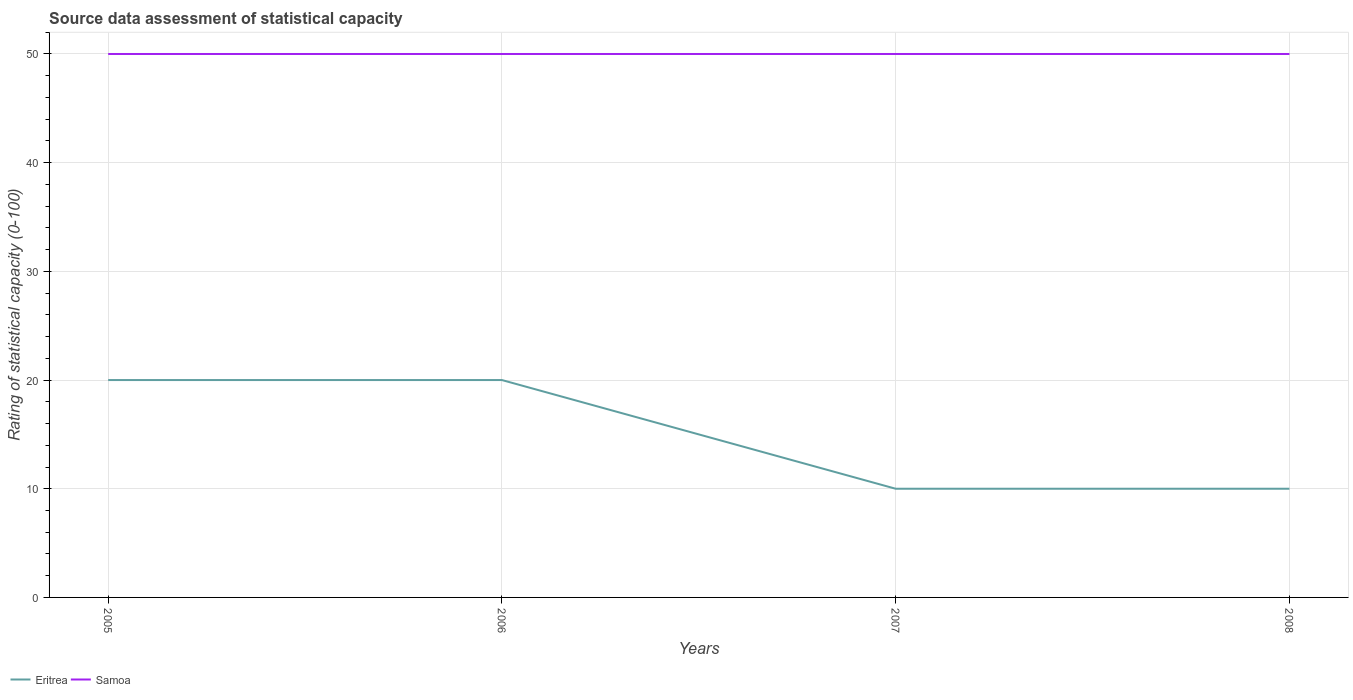How many different coloured lines are there?
Your answer should be very brief. 2. Is the number of lines equal to the number of legend labels?
Ensure brevity in your answer.  Yes. Across all years, what is the maximum rating of statistical capacity in Eritrea?
Give a very brief answer. 10. In which year was the rating of statistical capacity in Eritrea maximum?
Ensure brevity in your answer.  2007. What is the total rating of statistical capacity in Eritrea in the graph?
Your answer should be compact. 10. How many years are there in the graph?
Ensure brevity in your answer.  4. Are the values on the major ticks of Y-axis written in scientific E-notation?
Your response must be concise. No. Does the graph contain any zero values?
Offer a terse response. No. Does the graph contain grids?
Make the answer very short. Yes. How are the legend labels stacked?
Provide a short and direct response. Horizontal. What is the title of the graph?
Make the answer very short. Source data assessment of statistical capacity. Does "Pacific island small states" appear as one of the legend labels in the graph?
Give a very brief answer. No. What is the label or title of the Y-axis?
Your response must be concise. Rating of statistical capacity (0-100). What is the Rating of statistical capacity (0-100) in Samoa in 2006?
Your answer should be compact. 50. What is the Rating of statistical capacity (0-100) of Samoa in 2007?
Offer a terse response. 50. Across all years, what is the maximum Rating of statistical capacity (0-100) in Eritrea?
Ensure brevity in your answer.  20. Across all years, what is the maximum Rating of statistical capacity (0-100) of Samoa?
Your answer should be compact. 50. What is the total Rating of statistical capacity (0-100) of Samoa in the graph?
Your response must be concise. 200. What is the difference between the Rating of statistical capacity (0-100) in Eritrea in 2005 and that in 2007?
Ensure brevity in your answer.  10. What is the difference between the Rating of statistical capacity (0-100) in Samoa in 2005 and that in 2007?
Provide a short and direct response. 0. What is the difference between the Rating of statistical capacity (0-100) in Eritrea in 2005 and that in 2008?
Make the answer very short. 10. What is the difference between the Rating of statistical capacity (0-100) in Samoa in 2005 and that in 2008?
Provide a short and direct response. 0. What is the difference between the Rating of statistical capacity (0-100) in Samoa in 2006 and that in 2008?
Your response must be concise. 0. What is the difference between the Rating of statistical capacity (0-100) of Eritrea in 2005 and the Rating of statistical capacity (0-100) of Samoa in 2007?
Offer a terse response. -30. What is the difference between the Rating of statistical capacity (0-100) in Eritrea in 2006 and the Rating of statistical capacity (0-100) in Samoa in 2007?
Your response must be concise. -30. What is the difference between the Rating of statistical capacity (0-100) of Eritrea in 2006 and the Rating of statistical capacity (0-100) of Samoa in 2008?
Keep it short and to the point. -30. In the year 2007, what is the difference between the Rating of statistical capacity (0-100) in Eritrea and Rating of statistical capacity (0-100) in Samoa?
Offer a terse response. -40. In the year 2008, what is the difference between the Rating of statistical capacity (0-100) in Eritrea and Rating of statistical capacity (0-100) in Samoa?
Provide a short and direct response. -40. What is the ratio of the Rating of statistical capacity (0-100) in Eritrea in 2005 to that in 2006?
Your answer should be very brief. 1. What is the ratio of the Rating of statistical capacity (0-100) of Eritrea in 2005 to that in 2007?
Your response must be concise. 2. What is the ratio of the Rating of statistical capacity (0-100) in Samoa in 2005 to that in 2007?
Offer a very short reply. 1. What is the ratio of the Rating of statistical capacity (0-100) in Samoa in 2005 to that in 2008?
Make the answer very short. 1. What is the ratio of the Rating of statistical capacity (0-100) in Eritrea in 2006 to that in 2007?
Ensure brevity in your answer.  2. What is the ratio of the Rating of statistical capacity (0-100) of Samoa in 2006 to that in 2007?
Ensure brevity in your answer.  1. What is the ratio of the Rating of statistical capacity (0-100) of Samoa in 2006 to that in 2008?
Offer a very short reply. 1. What is the ratio of the Rating of statistical capacity (0-100) in Eritrea in 2007 to that in 2008?
Ensure brevity in your answer.  1. What is the ratio of the Rating of statistical capacity (0-100) in Samoa in 2007 to that in 2008?
Offer a terse response. 1. What is the difference between the highest and the second highest Rating of statistical capacity (0-100) in Eritrea?
Your answer should be very brief. 0. What is the difference between the highest and the second highest Rating of statistical capacity (0-100) of Samoa?
Provide a succinct answer. 0. 